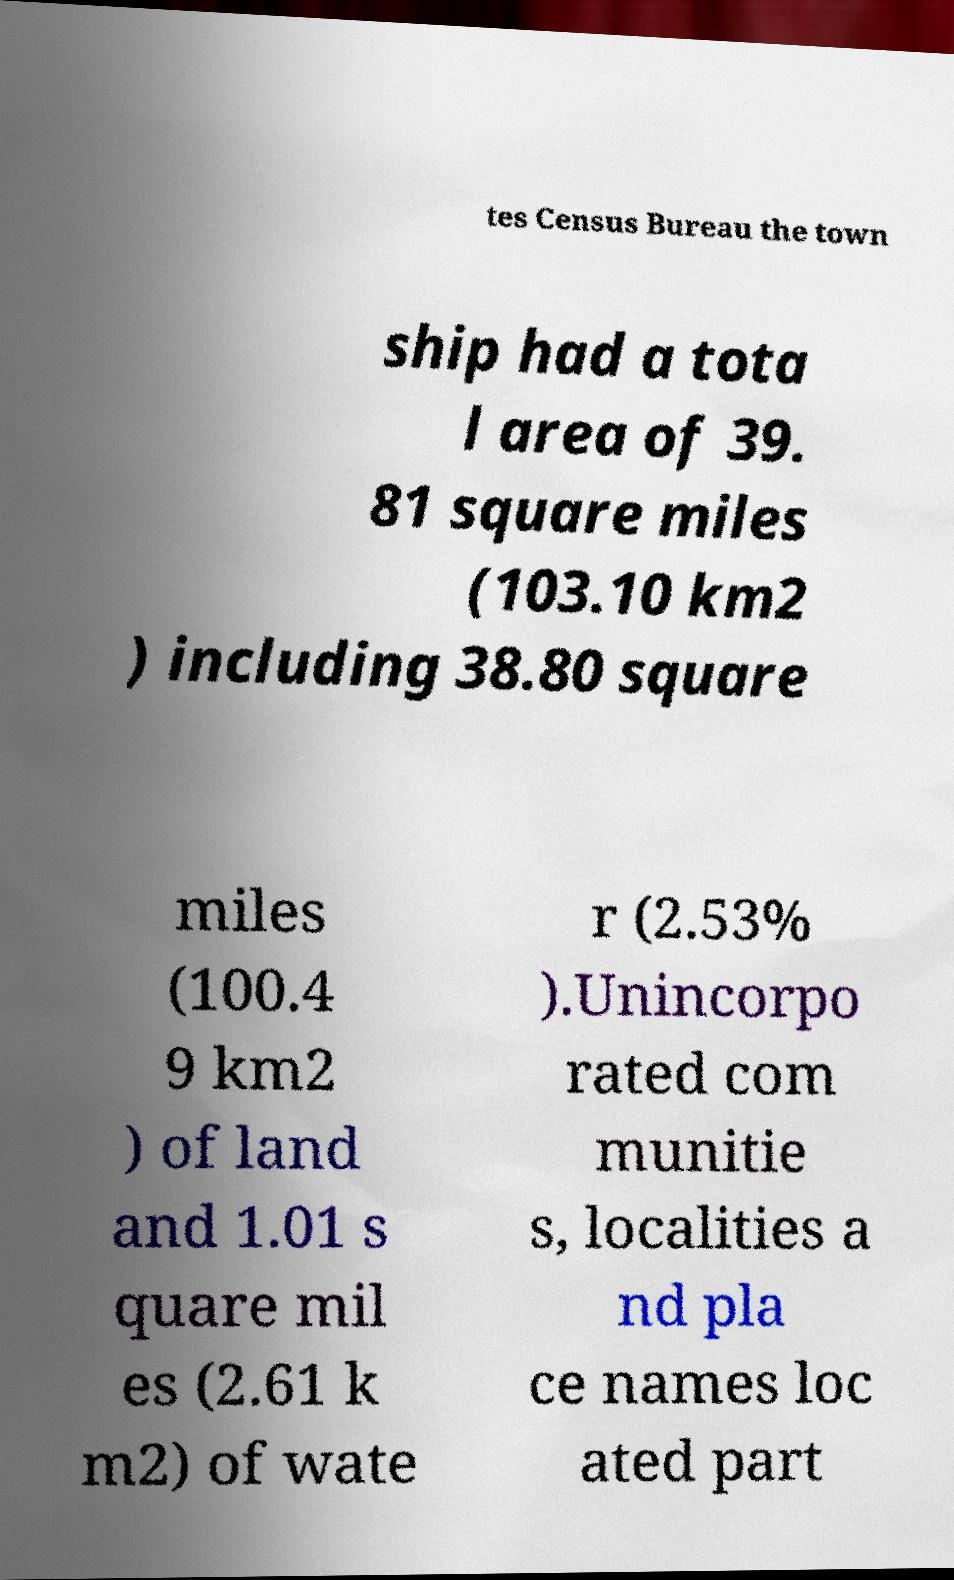Can you read and provide the text displayed in the image?This photo seems to have some interesting text. Can you extract and type it out for me? tes Census Bureau the town ship had a tota l area of 39. 81 square miles (103.10 km2 ) including 38.80 square miles (100.4 9 km2 ) of land and 1.01 s quare mil es (2.61 k m2) of wate r (2.53% ).Unincorpo rated com munitie s, localities a nd pla ce names loc ated part 